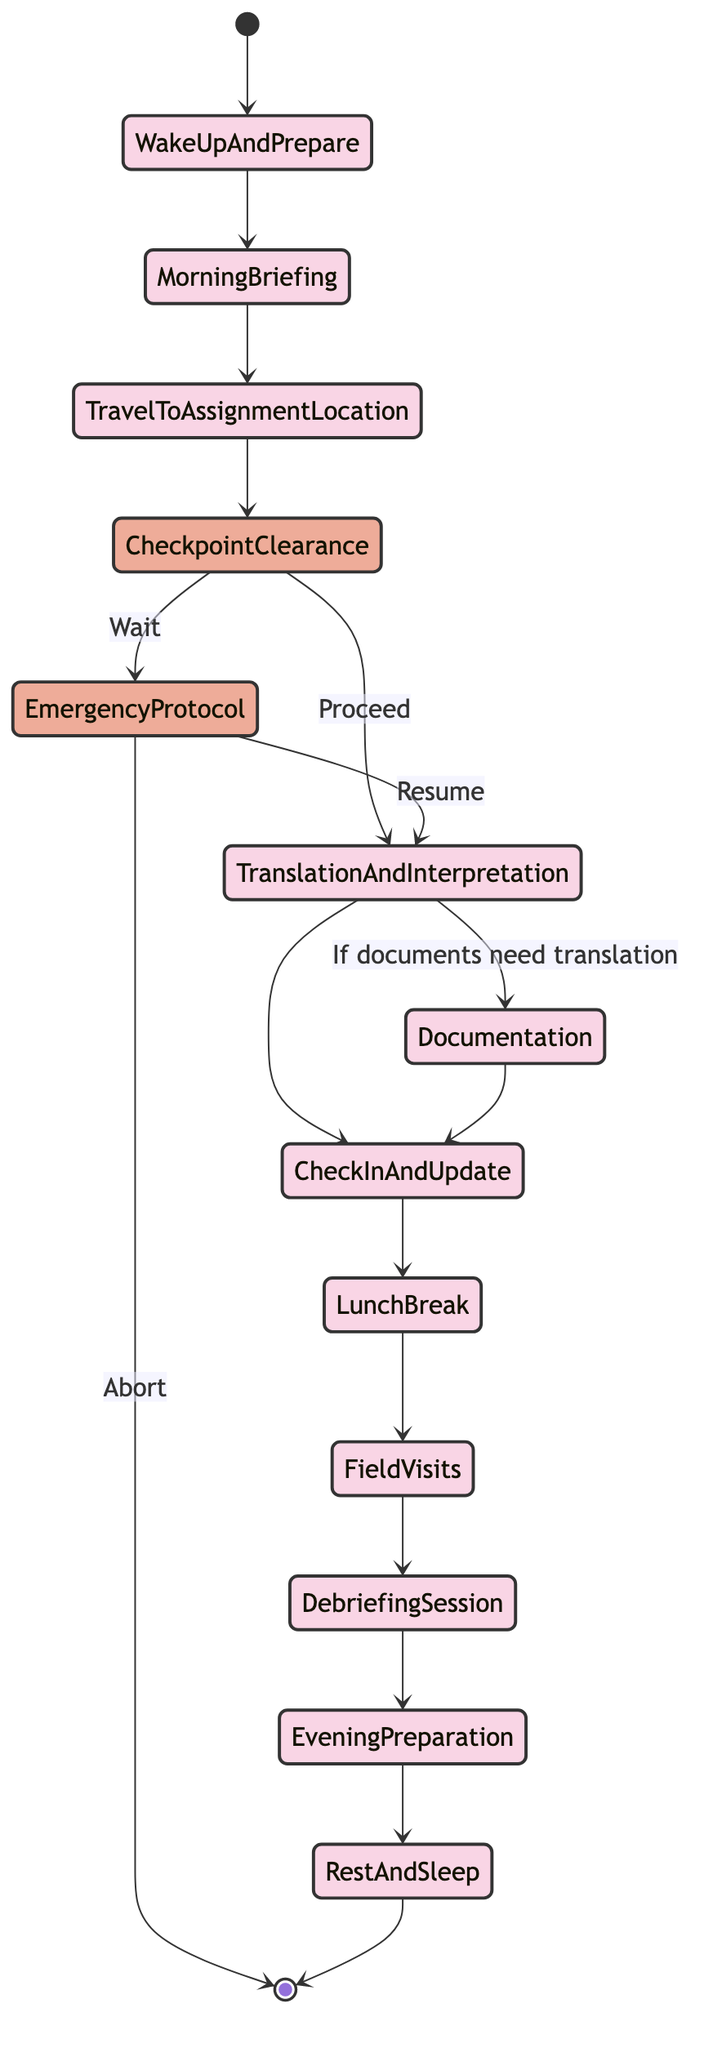What is the first activity in the diagram? The diagram starts with the state labeled "Wake Up and Prepare," indicating it is the first activity that occurs in the daily routine.
Answer: Wake Up and Prepare How many activities are there in total? Counting the states in the diagram, there are eleven activity states: Wake Up and Prepare, Morning Briefing, Travel to Assignment Location, Translation and Interpretation, Documentation, Check-In and Update, Lunch Break, Field Visits, Debriefing Session, Evening Preparation, and Rest and Sleep. Thus, the total is eleven.
Answer: 11 What follows the "Translation and Interpretation" activity if documents need translation? According to the flow from "Translation and Interpretation," if documents need translation, the next activity is "Documentation."
Answer: Documentation What decision point comes after "Travel to Assignment Location"? Following "Travel to Assignment Location," the next element is the decision point labeled "Checkpoint Clearance," as indicated by the flow from the previous activity to this decision.
Answer: Checkpoint Clearance In how many scenarios can "Emergency Protocol" be activated? The "Emergency Protocol" can be activated in two scenarios as it branches from "Checkpoint Clearance," determining either to "Wait" or "Resume" the process after an emergency situation.
Answer: 2 What is the last activity before resting? The last activity before "Rest and Sleep" is "Evening Preparation," which shows a clear sequential flow leading into the final activity for the day.
Answer: Evening Preparation If an emergency occurs, what is the initial action? If an emergency arises, the initial action according to the flow indicates that the response is to "Abort," which is indicated as an outcome of the "Emergency Protocol" decision.
Answer: Abort How many decision points are present in the diagram? There are two decision points depicted in the diagram: "Checkpoint Clearance" and "Emergency Protocol," thus the total count is two.
Answer: 2 What activity occurs immediately after "Lunch Break"? After "Lunch Break," the next activity specified in the flow is "Field Visits," indicating the continuation of the daily routine.
Answer: Field Visits What happens if the decision at "Checkpoint Clearance" is to wait? If the decision at "Checkpoint Clearance" is to "Wait," the flow indicates that it leads to the activation of "Emergency Protocol," signaling an unforeseen situation needing assessment.
Answer: Emergency Protocol 